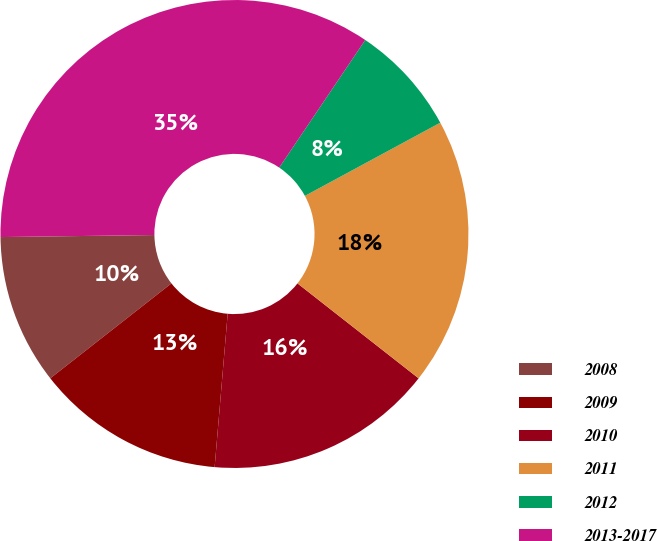Convert chart. <chart><loc_0><loc_0><loc_500><loc_500><pie_chart><fcel>2008<fcel>2009<fcel>2010<fcel>2011<fcel>2012<fcel>2013-2017<nl><fcel>10.37%<fcel>13.07%<fcel>15.77%<fcel>18.47%<fcel>7.67%<fcel>34.65%<nl></chart> 